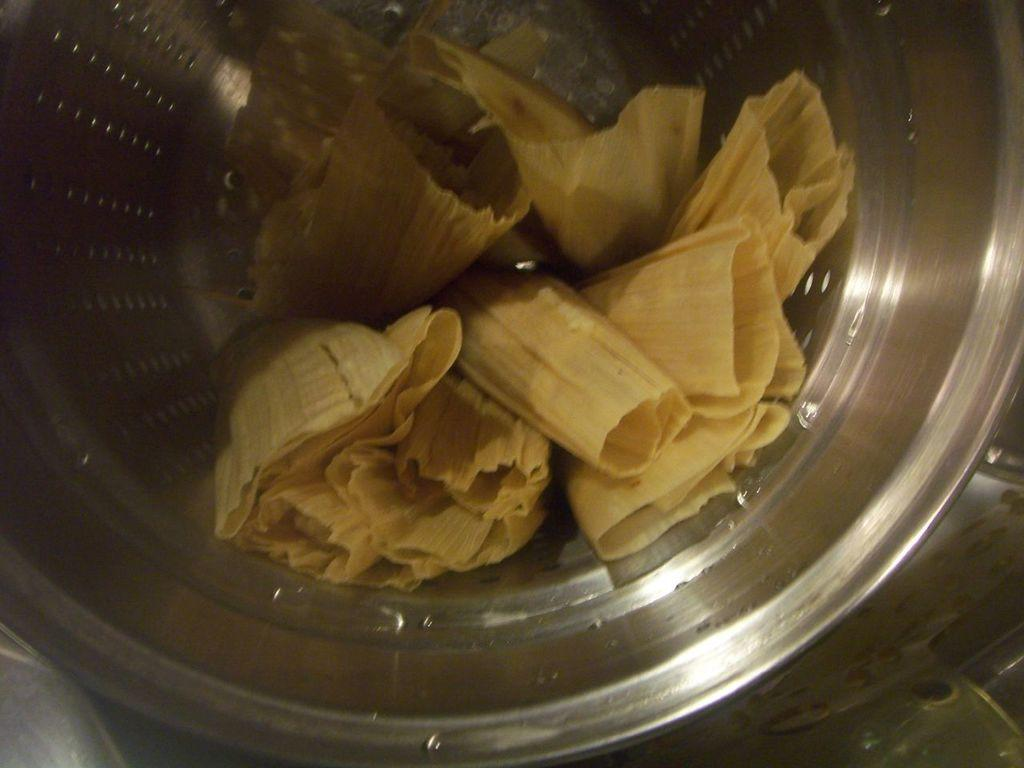What object can be seen in the image that is typically used for waste disposal? There is a dustbin in the image. What is inside the dustbin? The dustbin appears to contain garbage. What type of jewel can be seen sparkling in the dustbin? There is no jewel present in the dustbin; it contains garbage. 